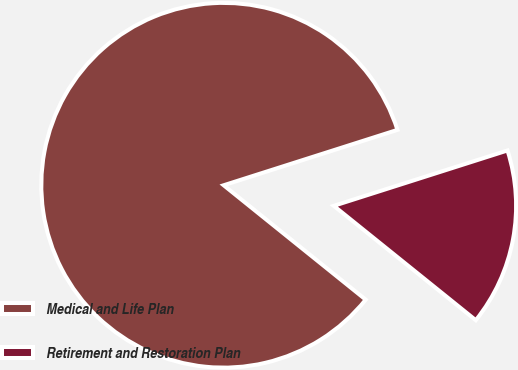Convert chart to OTSL. <chart><loc_0><loc_0><loc_500><loc_500><pie_chart><fcel>Medical and Life Plan<fcel>Retirement and Restoration Plan<nl><fcel>84.3%<fcel>15.7%<nl></chart> 